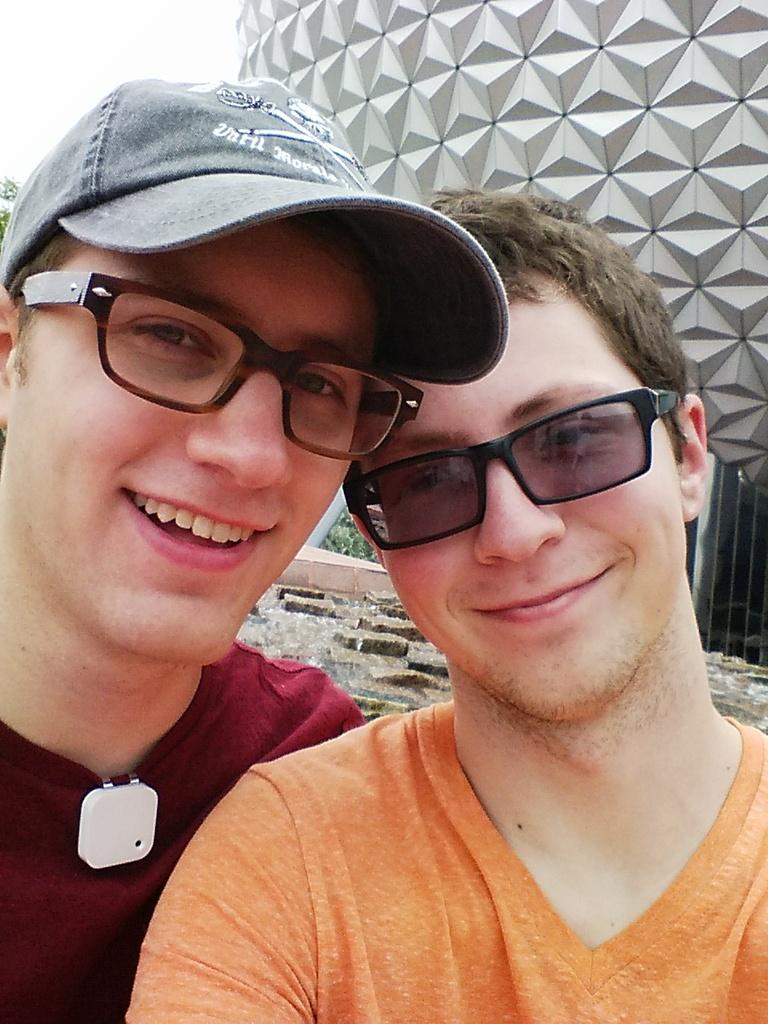How many people are in the image? There are two men in the image. What are the men wearing? Both men are wearing clothes. What accessory do the men have in common? Both men are wearing glasses. What type of rule does the man on the left follow in the image? There is no indication of any rules being followed in the image, as it only shows two men wearing glasses and clothes. 